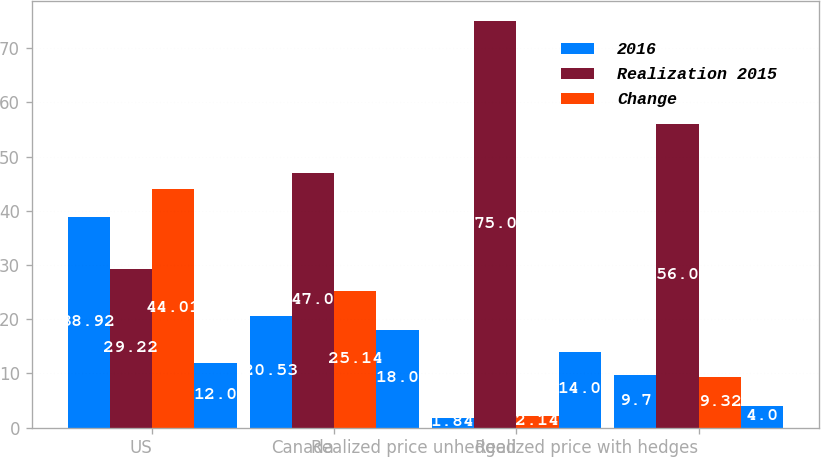Convert chart to OTSL. <chart><loc_0><loc_0><loc_500><loc_500><stacked_bar_chart><ecel><fcel>US<fcel>Canada<fcel>Realized price unhedged<fcel>Realized price with hedges<nl><fcel>2016<fcel>38.92<fcel>20.53<fcel>1.84<fcel>9.7<nl><fcel>Realization 2015<fcel>29.22<fcel>47<fcel>75<fcel>56<nl><fcel>Change<fcel>44.01<fcel>25.14<fcel>2.14<fcel>9.32<nl><fcel>nan<fcel>12<fcel>18<fcel>14<fcel>4<nl></chart> 